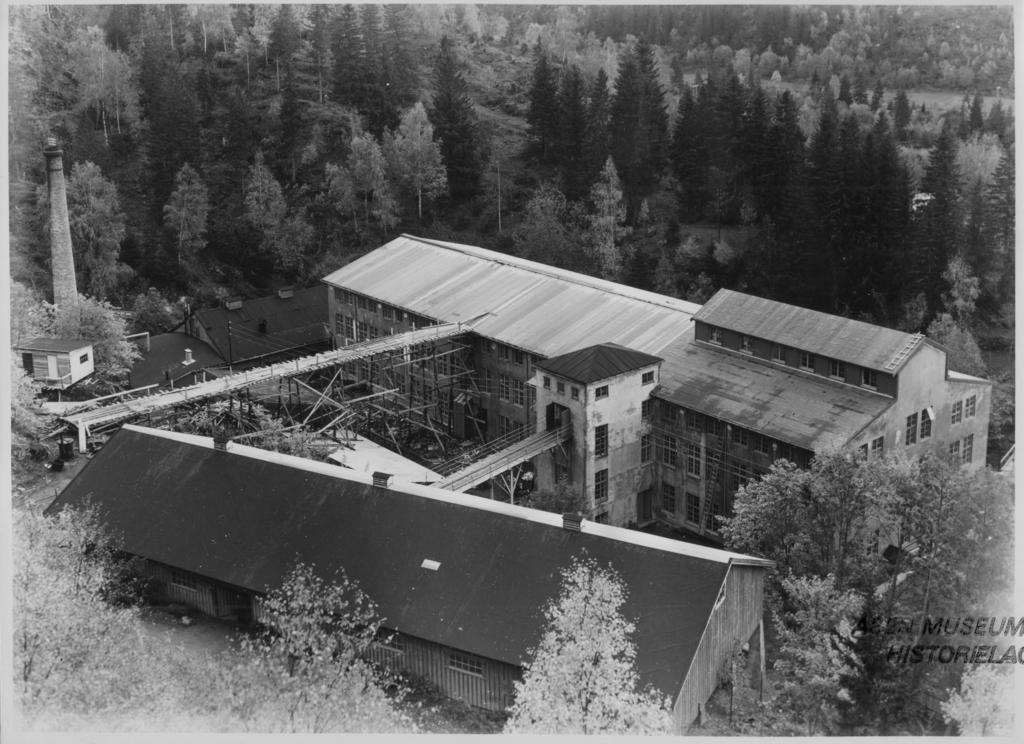What is the color scheme of the image? The image is black and white. What type of natural elements can be seen in the image? There are trees in the image. What type of man-made structure is present in the image? There is a factory in the image. Where is the text located in the image? The text is in the bottom right corner of the image. What type of birds can be seen flying in the image? There are no birds visible in the image, as it is black and white and only features trees, a factory, and text. What month is it in the image? The image does not provide any information about the month or time of year. 